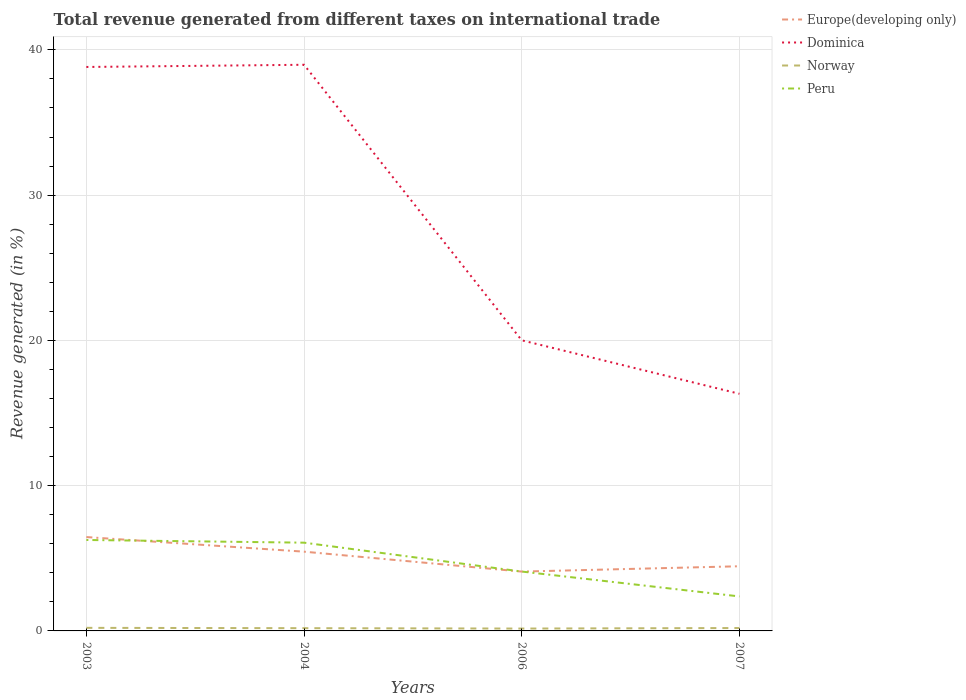How many different coloured lines are there?
Your response must be concise. 4. Does the line corresponding to Norway intersect with the line corresponding to Europe(developing only)?
Keep it short and to the point. No. Is the number of lines equal to the number of legend labels?
Provide a succinct answer. Yes. Across all years, what is the maximum total revenue generated in Norway?
Ensure brevity in your answer.  0.16. In which year was the total revenue generated in Peru maximum?
Offer a terse response. 2007. What is the total total revenue generated in Norway in the graph?
Give a very brief answer. -0.01. What is the difference between the highest and the second highest total revenue generated in Norway?
Your answer should be very brief. 0.05. Is the total revenue generated in Peru strictly greater than the total revenue generated in Dominica over the years?
Give a very brief answer. Yes. How many years are there in the graph?
Keep it short and to the point. 4. Are the values on the major ticks of Y-axis written in scientific E-notation?
Your response must be concise. No. Does the graph contain grids?
Offer a terse response. Yes. Where does the legend appear in the graph?
Offer a very short reply. Top right. How many legend labels are there?
Keep it short and to the point. 4. What is the title of the graph?
Give a very brief answer. Total revenue generated from different taxes on international trade. Does "Euro area" appear as one of the legend labels in the graph?
Your answer should be compact. No. What is the label or title of the X-axis?
Provide a short and direct response. Years. What is the label or title of the Y-axis?
Keep it short and to the point. Revenue generated (in %). What is the Revenue generated (in %) in Europe(developing only) in 2003?
Give a very brief answer. 6.46. What is the Revenue generated (in %) of Dominica in 2003?
Your response must be concise. 38.82. What is the Revenue generated (in %) in Norway in 2003?
Your response must be concise. 0.21. What is the Revenue generated (in %) in Peru in 2003?
Your answer should be very brief. 6.26. What is the Revenue generated (in %) of Europe(developing only) in 2004?
Offer a very short reply. 5.46. What is the Revenue generated (in %) of Dominica in 2004?
Offer a very short reply. 38.97. What is the Revenue generated (in %) in Norway in 2004?
Keep it short and to the point. 0.19. What is the Revenue generated (in %) of Peru in 2004?
Provide a succinct answer. 6.08. What is the Revenue generated (in %) in Europe(developing only) in 2006?
Ensure brevity in your answer.  4.08. What is the Revenue generated (in %) in Dominica in 2006?
Provide a short and direct response. 20.01. What is the Revenue generated (in %) of Norway in 2006?
Make the answer very short. 0.16. What is the Revenue generated (in %) in Peru in 2006?
Offer a terse response. 4.09. What is the Revenue generated (in %) in Europe(developing only) in 2007?
Your answer should be very brief. 4.45. What is the Revenue generated (in %) in Dominica in 2007?
Keep it short and to the point. 16.32. What is the Revenue generated (in %) of Norway in 2007?
Provide a short and direct response. 0.2. What is the Revenue generated (in %) of Peru in 2007?
Ensure brevity in your answer.  2.37. Across all years, what is the maximum Revenue generated (in %) in Europe(developing only)?
Offer a terse response. 6.46. Across all years, what is the maximum Revenue generated (in %) of Dominica?
Your answer should be very brief. 38.97. Across all years, what is the maximum Revenue generated (in %) in Norway?
Provide a succinct answer. 0.21. Across all years, what is the maximum Revenue generated (in %) in Peru?
Your answer should be very brief. 6.26. Across all years, what is the minimum Revenue generated (in %) of Europe(developing only)?
Ensure brevity in your answer.  4.08. Across all years, what is the minimum Revenue generated (in %) of Dominica?
Your answer should be compact. 16.32. Across all years, what is the minimum Revenue generated (in %) in Norway?
Keep it short and to the point. 0.16. Across all years, what is the minimum Revenue generated (in %) of Peru?
Your response must be concise. 2.37. What is the total Revenue generated (in %) in Europe(developing only) in the graph?
Keep it short and to the point. 20.45. What is the total Revenue generated (in %) of Dominica in the graph?
Keep it short and to the point. 114.12. What is the total Revenue generated (in %) in Norway in the graph?
Offer a terse response. 0.76. What is the total Revenue generated (in %) in Peru in the graph?
Provide a short and direct response. 18.8. What is the difference between the Revenue generated (in %) of Dominica in 2003 and that in 2004?
Offer a very short reply. -0.15. What is the difference between the Revenue generated (in %) of Norway in 2003 and that in 2004?
Your answer should be very brief. 0.02. What is the difference between the Revenue generated (in %) of Peru in 2003 and that in 2004?
Your response must be concise. 0.19. What is the difference between the Revenue generated (in %) of Europe(developing only) in 2003 and that in 2006?
Your answer should be very brief. 2.38. What is the difference between the Revenue generated (in %) of Dominica in 2003 and that in 2006?
Provide a succinct answer. 18.82. What is the difference between the Revenue generated (in %) in Norway in 2003 and that in 2006?
Offer a terse response. 0.05. What is the difference between the Revenue generated (in %) in Peru in 2003 and that in 2006?
Your response must be concise. 2.17. What is the difference between the Revenue generated (in %) of Europe(developing only) in 2003 and that in 2007?
Your answer should be very brief. 2.01. What is the difference between the Revenue generated (in %) in Dominica in 2003 and that in 2007?
Offer a terse response. 22.5. What is the difference between the Revenue generated (in %) of Norway in 2003 and that in 2007?
Provide a short and direct response. 0.01. What is the difference between the Revenue generated (in %) in Peru in 2003 and that in 2007?
Provide a succinct answer. 3.89. What is the difference between the Revenue generated (in %) of Europe(developing only) in 2004 and that in 2006?
Make the answer very short. 1.37. What is the difference between the Revenue generated (in %) in Dominica in 2004 and that in 2006?
Your answer should be compact. 18.97. What is the difference between the Revenue generated (in %) in Norway in 2004 and that in 2006?
Provide a short and direct response. 0.03. What is the difference between the Revenue generated (in %) of Peru in 2004 and that in 2006?
Ensure brevity in your answer.  1.99. What is the difference between the Revenue generated (in %) in Dominica in 2004 and that in 2007?
Make the answer very short. 22.65. What is the difference between the Revenue generated (in %) in Norway in 2004 and that in 2007?
Your answer should be very brief. -0.01. What is the difference between the Revenue generated (in %) in Peru in 2004 and that in 2007?
Your answer should be very brief. 3.7. What is the difference between the Revenue generated (in %) in Europe(developing only) in 2006 and that in 2007?
Offer a very short reply. -0.37. What is the difference between the Revenue generated (in %) of Dominica in 2006 and that in 2007?
Provide a succinct answer. 3.68. What is the difference between the Revenue generated (in %) of Norway in 2006 and that in 2007?
Your answer should be compact. -0.04. What is the difference between the Revenue generated (in %) in Peru in 2006 and that in 2007?
Give a very brief answer. 1.71. What is the difference between the Revenue generated (in %) of Europe(developing only) in 2003 and the Revenue generated (in %) of Dominica in 2004?
Your answer should be compact. -32.51. What is the difference between the Revenue generated (in %) of Europe(developing only) in 2003 and the Revenue generated (in %) of Norway in 2004?
Keep it short and to the point. 6.27. What is the difference between the Revenue generated (in %) in Europe(developing only) in 2003 and the Revenue generated (in %) in Peru in 2004?
Provide a succinct answer. 0.39. What is the difference between the Revenue generated (in %) in Dominica in 2003 and the Revenue generated (in %) in Norway in 2004?
Your answer should be compact. 38.63. What is the difference between the Revenue generated (in %) of Dominica in 2003 and the Revenue generated (in %) of Peru in 2004?
Your answer should be compact. 32.75. What is the difference between the Revenue generated (in %) of Norway in 2003 and the Revenue generated (in %) of Peru in 2004?
Offer a terse response. -5.86. What is the difference between the Revenue generated (in %) of Europe(developing only) in 2003 and the Revenue generated (in %) of Dominica in 2006?
Make the answer very short. -13.55. What is the difference between the Revenue generated (in %) in Europe(developing only) in 2003 and the Revenue generated (in %) in Norway in 2006?
Offer a terse response. 6.3. What is the difference between the Revenue generated (in %) of Europe(developing only) in 2003 and the Revenue generated (in %) of Peru in 2006?
Make the answer very short. 2.37. What is the difference between the Revenue generated (in %) in Dominica in 2003 and the Revenue generated (in %) in Norway in 2006?
Provide a succinct answer. 38.66. What is the difference between the Revenue generated (in %) of Dominica in 2003 and the Revenue generated (in %) of Peru in 2006?
Ensure brevity in your answer.  34.73. What is the difference between the Revenue generated (in %) in Norway in 2003 and the Revenue generated (in %) in Peru in 2006?
Offer a terse response. -3.88. What is the difference between the Revenue generated (in %) in Europe(developing only) in 2003 and the Revenue generated (in %) in Dominica in 2007?
Provide a short and direct response. -9.86. What is the difference between the Revenue generated (in %) of Europe(developing only) in 2003 and the Revenue generated (in %) of Norway in 2007?
Keep it short and to the point. 6.26. What is the difference between the Revenue generated (in %) of Europe(developing only) in 2003 and the Revenue generated (in %) of Peru in 2007?
Give a very brief answer. 4.09. What is the difference between the Revenue generated (in %) of Dominica in 2003 and the Revenue generated (in %) of Norway in 2007?
Give a very brief answer. 38.62. What is the difference between the Revenue generated (in %) of Dominica in 2003 and the Revenue generated (in %) of Peru in 2007?
Provide a short and direct response. 36.45. What is the difference between the Revenue generated (in %) of Norway in 2003 and the Revenue generated (in %) of Peru in 2007?
Your answer should be compact. -2.16. What is the difference between the Revenue generated (in %) in Europe(developing only) in 2004 and the Revenue generated (in %) in Dominica in 2006?
Keep it short and to the point. -14.55. What is the difference between the Revenue generated (in %) of Europe(developing only) in 2004 and the Revenue generated (in %) of Norway in 2006?
Give a very brief answer. 5.29. What is the difference between the Revenue generated (in %) of Europe(developing only) in 2004 and the Revenue generated (in %) of Peru in 2006?
Your response must be concise. 1.37. What is the difference between the Revenue generated (in %) in Dominica in 2004 and the Revenue generated (in %) in Norway in 2006?
Offer a very short reply. 38.81. What is the difference between the Revenue generated (in %) of Dominica in 2004 and the Revenue generated (in %) of Peru in 2006?
Offer a terse response. 34.89. What is the difference between the Revenue generated (in %) in Norway in 2004 and the Revenue generated (in %) in Peru in 2006?
Your answer should be compact. -3.9. What is the difference between the Revenue generated (in %) in Europe(developing only) in 2004 and the Revenue generated (in %) in Dominica in 2007?
Provide a short and direct response. -10.87. What is the difference between the Revenue generated (in %) of Europe(developing only) in 2004 and the Revenue generated (in %) of Norway in 2007?
Your answer should be compact. 5.26. What is the difference between the Revenue generated (in %) in Europe(developing only) in 2004 and the Revenue generated (in %) in Peru in 2007?
Make the answer very short. 3.08. What is the difference between the Revenue generated (in %) in Dominica in 2004 and the Revenue generated (in %) in Norway in 2007?
Offer a terse response. 38.77. What is the difference between the Revenue generated (in %) of Dominica in 2004 and the Revenue generated (in %) of Peru in 2007?
Offer a terse response. 36.6. What is the difference between the Revenue generated (in %) of Norway in 2004 and the Revenue generated (in %) of Peru in 2007?
Offer a very short reply. -2.19. What is the difference between the Revenue generated (in %) in Europe(developing only) in 2006 and the Revenue generated (in %) in Dominica in 2007?
Give a very brief answer. -12.24. What is the difference between the Revenue generated (in %) of Europe(developing only) in 2006 and the Revenue generated (in %) of Norway in 2007?
Keep it short and to the point. 3.89. What is the difference between the Revenue generated (in %) of Europe(developing only) in 2006 and the Revenue generated (in %) of Peru in 2007?
Ensure brevity in your answer.  1.71. What is the difference between the Revenue generated (in %) of Dominica in 2006 and the Revenue generated (in %) of Norway in 2007?
Your response must be concise. 19.81. What is the difference between the Revenue generated (in %) of Dominica in 2006 and the Revenue generated (in %) of Peru in 2007?
Provide a succinct answer. 17.63. What is the difference between the Revenue generated (in %) in Norway in 2006 and the Revenue generated (in %) in Peru in 2007?
Offer a terse response. -2.21. What is the average Revenue generated (in %) in Europe(developing only) per year?
Offer a terse response. 5.11. What is the average Revenue generated (in %) of Dominica per year?
Provide a succinct answer. 28.53. What is the average Revenue generated (in %) of Norway per year?
Provide a short and direct response. 0.19. What is the average Revenue generated (in %) of Peru per year?
Your answer should be compact. 4.7. In the year 2003, what is the difference between the Revenue generated (in %) in Europe(developing only) and Revenue generated (in %) in Dominica?
Keep it short and to the point. -32.36. In the year 2003, what is the difference between the Revenue generated (in %) of Europe(developing only) and Revenue generated (in %) of Norway?
Make the answer very short. 6.25. In the year 2003, what is the difference between the Revenue generated (in %) in Europe(developing only) and Revenue generated (in %) in Peru?
Provide a short and direct response. 0.2. In the year 2003, what is the difference between the Revenue generated (in %) of Dominica and Revenue generated (in %) of Norway?
Provide a succinct answer. 38.61. In the year 2003, what is the difference between the Revenue generated (in %) of Dominica and Revenue generated (in %) of Peru?
Provide a short and direct response. 32.56. In the year 2003, what is the difference between the Revenue generated (in %) in Norway and Revenue generated (in %) in Peru?
Your answer should be compact. -6.05. In the year 2004, what is the difference between the Revenue generated (in %) of Europe(developing only) and Revenue generated (in %) of Dominica?
Make the answer very short. -33.52. In the year 2004, what is the difference between the Revenue generated (in %) of Europe(developing only) and Revenue generated (in %) of Norway?
Give a very brief answer. 5.27. In the year 2004, what is the difference between the Revenue generated (in %) in Europe(developing only) and Revenue generated (in %) in Peru?
Give a very brief answer. -0.62. In the year 2004, what is the difference between the Revenue generated (in %) in Dominica and Revenue generated (in %) in Norway?
Offer a very short reply. 38.78. In the year 2004, what is the difference between the Revenue generated (in %) in Dominica and Revenue generated (in %) in Peru?
Provide a succinct answer. 32.9. In the year 2004, what is the difference between the Revenue generated (in %) of Norway and Revenue generated (in %) of Peru?
Make the answer very short. -5.89. In the year 2006, what is the difference between the Revenue generated (in %) of Europe(developing only) and Revenue generated (in %) of Dominica?
Give a very brief answer. -15.92. In the year 2006, what is the difference between the Revenue generated (in %) of Europe(developing only) and Revenue generated (in %) of Norway?
Keep it short and to the point. 3.92. In the year 2006, what is the difference between the Revenue generated (in %) in Europe(developing only) and Revenue generated (in %) in Peru?
Offer a very short reply. -0. In the year 2006, what is the difference between the Revenue generated (in %) of Dominica and Revenue generated (in %) of Norway?
Offer a very short reply. 19.84. In the year 2006, what is the difference between the Revenue generated (in %) of Dominica and Revenue generated (in %) of Peru?
Make the answer very short. 15.92. In the year 2006, what is the difference between the Revenue generated (in %) of Norway and Revenue generated (in %) of Peru?
Offer a very short reply. -3.92. In the year 2007, what is the difference between the Revenue generated (in %) of Europe(developing only) and Revenue generated (in %) of Dominica?
Provide a short and direct response. -11.87. In the year 2007, what is the difference between the Revenue generated (in %) of Europe(developing only) and Revenue generated (in %) of Norway?
Your response must be concise. 4.25. In the year 2007, what is the difference between the Revenue generated (in %) of Europe(developing only) and Revenue generated (in %) of Peru?
Keep it short and to the point. 2.08. In the year 2007, what is the difference between the Revenue generated (in %) in Dominica and Revenue generated (in %) in Norway?
Provide a short and direct response. 16.12. In the year 2007, what is the difference between the Revenue generated (in %) in Dominica and Revenue generated (in %) in Peru?
Your answer should be very brief. 13.95. In the year 2007, what is the difference between the Revenue generated (in %) of Norway and Revenue generated (in %) of Peru?
Offer a very short reply. -2.18. What is the ratio of the Revenue generated (in %) of Europe(developing only) in 2003 to that in 2004?
Offer a terse response. 1.18. What is the ratio of the Revenue generated (in %) in Norway in 2003 to that in 2004?
Ensure brevity in your answer.  1.12. What is the ratio of the Revenue generated (in %) of Peru in 2003 to that in 2004?
Offer a very short reply. 1.03. What is the ratio of the Revenue generated (in %) of Europe(developing only) in 2003 to that in 2006?
Make the answer very short. 1.58. What is the ratio of the Revenue generated (in %) in Dominica in 2003 to that in 2006?
Give a very brief answer. 1.94. What is the ratio of the Revenue generated (in %) of Norway in 2003 to that in 2006?
Ensure brevity in your answer.  1.3. What is the ratio of the Revenue generated (in %) of Peru in 2003 to that in 2006?
Keep it short and to the point. 1.53. What is the ratio of the Revenue generated (in %) of Europe(developing only) in 2003 to that in 2007?
Your answer should be very brief. 1.45. What is the ratio of the Revenue generated (in %) in Dominica in 2003 to that in 2007?
Your response must be concise. 2.38. What is the ratio of the Revenue generated (in %) in Norway in 2003 to that in 2007?
Provide a short and direct response. 1.06. What is the ratio of the Revenue generated (in %) in Peru in 2003 to that in 2007?
Keep it short and to the point. 2.64. What is the ratio of the Revenue generated (in %) in Europe(developing only) in 2004 to that in 2006?
Ensure brevity in your answer.  1.34. What is the ratio of the Revenue generated (in %) of Dominica in 2004 to that in 2006?
Make the answer very short. 1.95. What is the ratio of the Revenue generated (in %) in Norway in 2004 to that in 2006?
Make the answer very short. 1.16. What is the ratio of the Revenue generated (in %) of Peru in 2004 to that in 2006?
Keep it short and to the point. 1.49. What is the ratio of the Revenue generated (in %) of Europe(developing only) in 2004 to that in 2007?
Your answer should be very brief. 1.23. What is the ratio of the Revenue generated (in %) of Dominica in 2004 to that in 2007?
Make the answer very short. 2.39. What is the ratio of the Revenue generated (in %) of Norway in 2004 to that in 2007?
Your response must be concise. 0.95. What is the ratio of the Revenue generated (in %) in Peru in 2004 to that in 2007?
Your answer should be very brief. 2.56. What is the ratio of the Revenue generated (in %) in Europe(developing only) in 2006 to that in 2007?
Give a very brief answer. 0.92. What is the ratio of the Revenue generated (in %) in Dominica in 2006 to that in 2007?
Make the answer very short. 1.23. What is the ratio of the Revenue generated (in %) of Norway in 2006 to that in 2007?
Make the answer very short. 0.82. What is the ratio of the Revenue generated (in %) in Peru in 2006 to that in 2007?
Provide a succinct answer. 1.72. What is the difference between the highest and the second highest Revenue generated (in %) in Dominica?
Your response must be concise. 0.15. What is the difference between the highest and the second highest Revenue generated (in %) in Norway?
Your response must be concise. 0.01. What is the difference between the highest and the second highest Revenue generated (in %) in Peru?
Ensure brevity in your answer.  0.19. What is the difference between the highest and the lowest Revenue generated (in %) of Europe(developing only)?
Make the answer very short. 2.38. What is the difference between the highest and the lowest Revenue generated (in %) of Dominica?
Your answer should be very brief. 22.65. What is the difference between the highest and the lowest Revenue generated (in %) of Norway?
Your answer should be very brief. 0.05. What is the difference between the highest and the lowest Revenue generated (in %) of Peru?
Your answer should be compact. 3.89. 